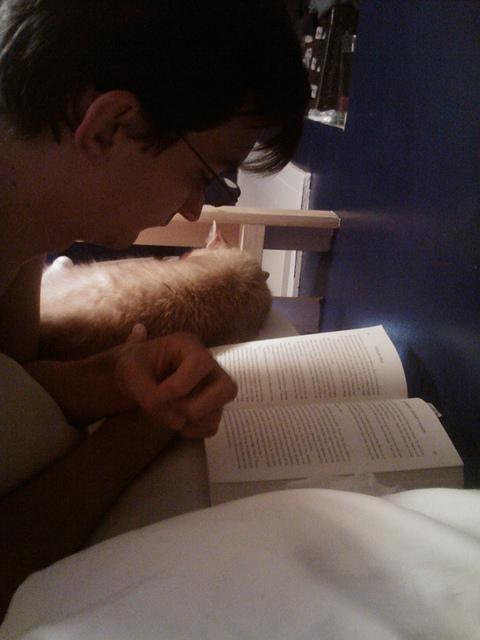How many books?
Give a very brief answer. 1. How many people can be seen?
Give a very brief answer. 1. 